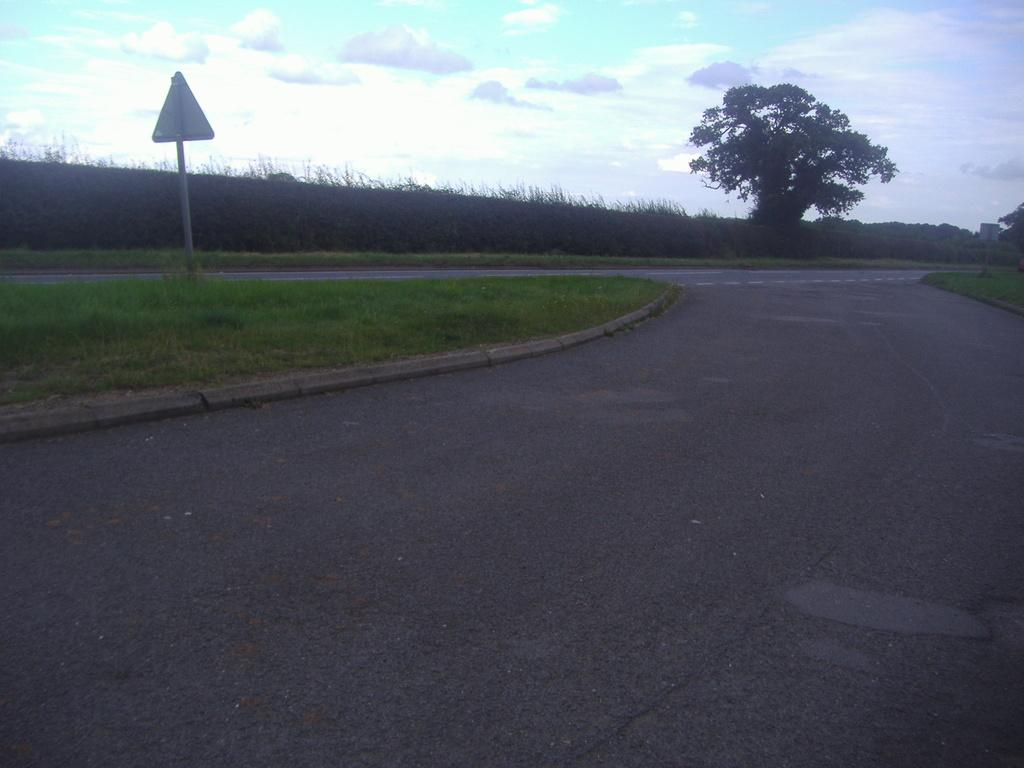What is the main feature of the image? There is a road in the image. Where is the sign board located in the image? The sign board is on the surface of the grass. What can be seen in the background of the image? There are trees and the sky visible in the background of the image. How many wrens are perched on the sign board in the image? There are no wrens present in the image. What type of experience does the carpenter have in the image? There is no carpenter present in the image. 